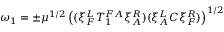Convert formula to latex. <formula><loc_0><loc_0><loc_500><loc_500>\omega _ { 1 } = \pm \mu ^ { 1 / 2 } \left ( ( \xi _ { F } ^ { L } T _ { 1 } ^ { F A } \xi _ { A } ^ { R } ) ( \xi _ { A } ^ { L } C \xi _ { F } ^ { R } ) \right ) ^ { 1 / 2 }</formula> 